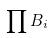<formula> <loc_0><loc_0><loc_500><loc_500>\prod B _ { i }</formula> 